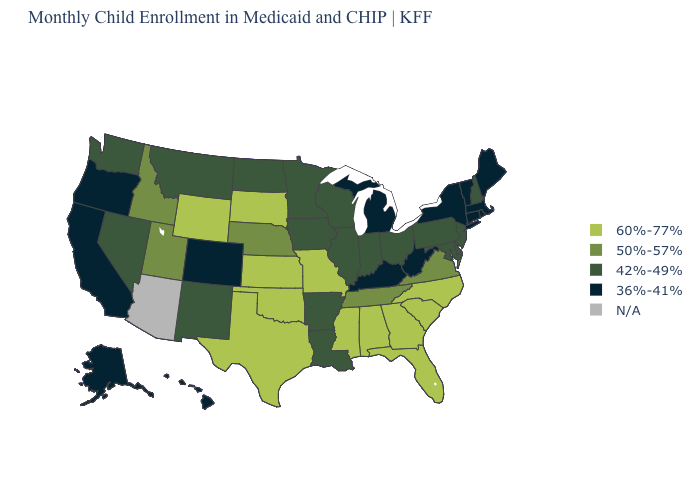Name the states that have a value in the range 60%-77%?
Short answer required. Alabama, Florida, Georgia, Kansas, Mississippi, Missouri, North Carolina, Oklahoma, South Carolina, South Dakota, Texas, Wyoming. Name the states that have a value in the range 36%-41%?
Concise answer only. Alaska, California, Colorado, Connecticut, Hawaii, Kentucky, Maine, Massachusetts, Michigan, New York, Oregon, Rhode Island, Vermont, West Virginia. What is the value of Hawaii?
Short answer required. 36%-41%. Among the states that border Oklahoma , does New Mexico have the highest value?
Answer briefly. No. Which states have the lowest value in the USA?
Short answer required. Alaska, California, Colorado, Connecticut, Hawaii, Kentucky, Maine, Massachusetts, Michigan, New York, Oregon, Rhode Island, Vermont, West Virginia. What is the highest value in the MidWest ?
Short answer required. 60%-77%. Which states hav the highest value in the Northeast?
Be succinct. New Hampshire, New Jersey, Pennsylvania. Name the states that have a value in the range 42%-49%?
Short answer required. Arkansas, Delaware, Illinois, Indiana, Iowa, Louisiana, Maryland, Minnesota, Montana, Nevada, New Hampshire, New Jersey, New Mexico, North Dakota, Ohio, Pennsylvania, Washington, Wisconsin. What is the value of Arizona?
Answer briefly. N/A. Name the states that have a value in the range N/A?
Concise answer only. Arizona. Name the states that have a value in the range 50%-57%?
Answer briefly. Idaho, Nebraska, Tennessee, Utah, Virginia. Does the first symbol in the legend represent the smallest category?
Be succinct. No. What is the value of Vermont?
Be succinct. 36%-41%. Name the states that have a value in the range 50%-57%?
Give a very brief answer. Idaho, Nebraska, Tennessee, Utah, Virginia. 